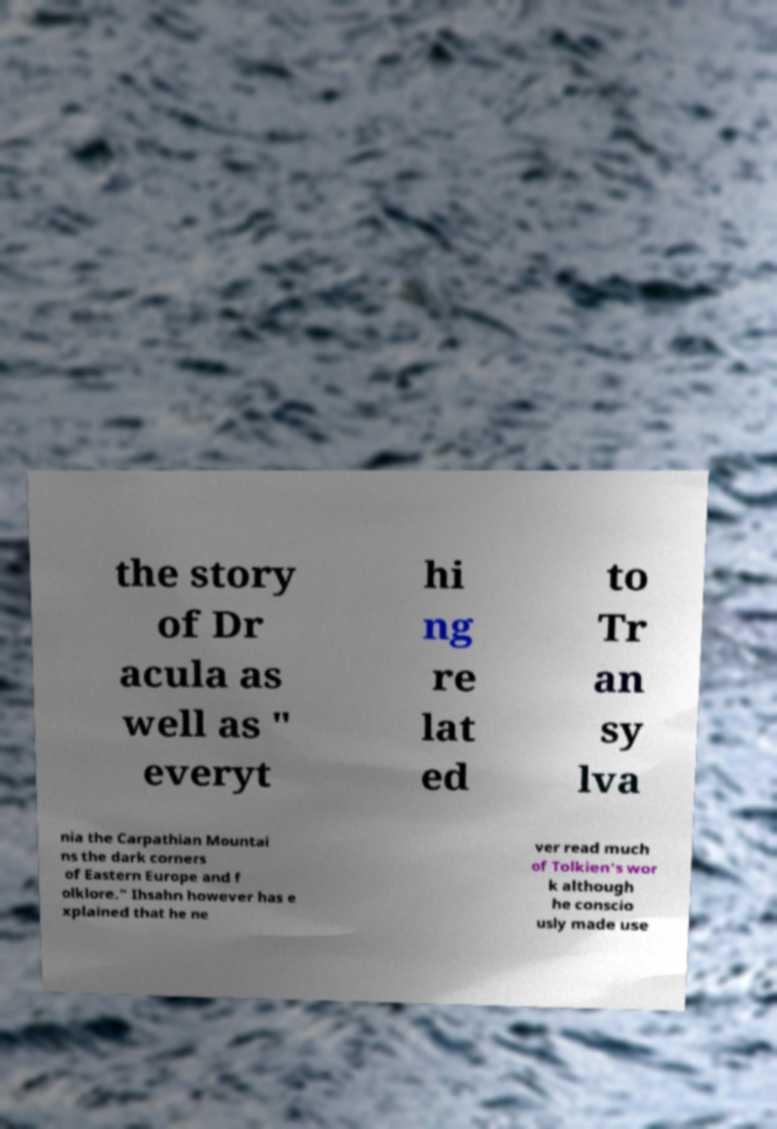There's text embedded in this image that I need extracted. Can you transcribe it verbatim? the story of Dr acula as well as " everyt hi ng re lat ed to Tr an sy lva nia the Carpathian Mountai ns the dark corners of Eastern Europe and f olklore." Ihsahn however has e xplained that he ne ver read much of Tolkien's wor k although he conscio usly made use 